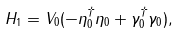<formula> <loc_0><loc_0><loc_500><loc_500>H _ { 1 } = V _ { 0 } ( - \eta ^ { \dag } _ { 0 } \eta _ { 0 } + \gamma ^ { \dag } _ { 0 } \gamma _ { 0 } ) ,</formula> 